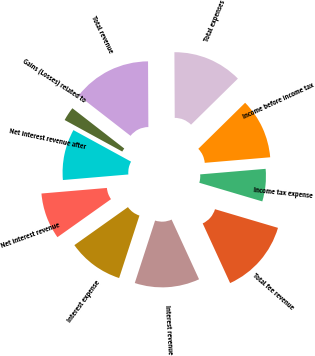Convert chart to OTSL. <chart><loc_0><loc_0><loc_500><loc_500><pie_chart><fcel>Total fee revenue<fcel>Interest revenue<fcel>Interest expense<fcel>Net interest revenue<fcel>Net interest revenue after<fcel>Gains (Losses) related to<fcel>Total revenue<fcel>Total expenses<fcel>Income before income tax<fcel>Income tax expense<nl><fcel>13.56%<fcel>11.86%<fcel>10.17%<fcel>8.47%<fcel>9.32%<fcel>2.54%<fcel>14.41%<fcel>12.71%<fcel>11.02%<fcel>5.93%<nl></chart> 